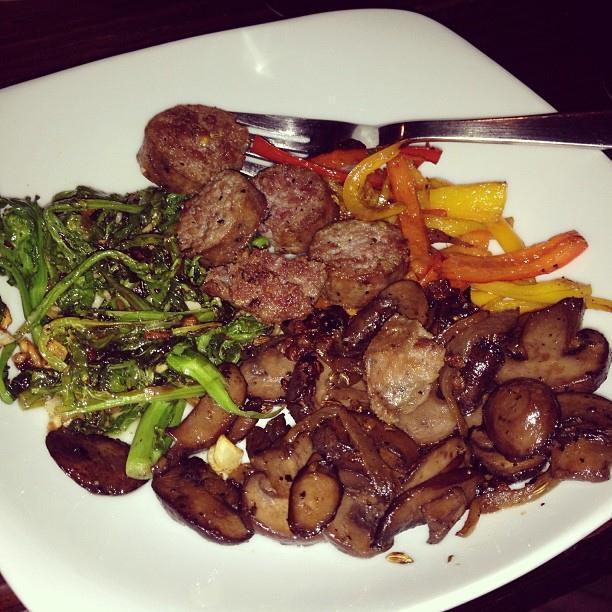How many broccolis are there?
Give a very brief answer. 2. 